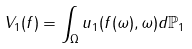Convert formula to latex. <formula><loc_0><loc_0><loc_500><loc_500>V _ { 1 } ( f ) = \int _ { \Omega } u _ { 1 } ( f ( \omega ) , \omega ) d \mathbb { P } _ { 1 }</formula> 